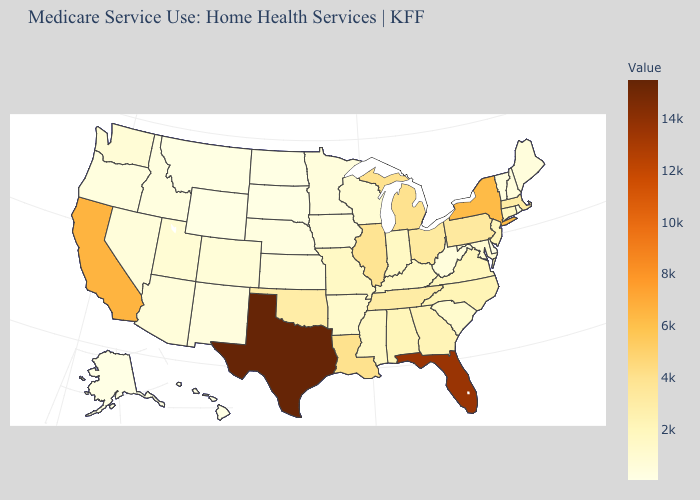Does New York have a higher value than Florida?
Write a very short answer. No. Which states have the lowest value in the Northeast?
Short answer required. Rhode Island. Is the legend a continuous bar?
Answer briefly. Yes. Which states have the lowest value in the USA?
Be succinct. Alaska. Which states have the lowest value in the USA?
Short answer required. Alaska. 